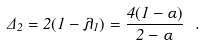Convert formula to latex. <formula><loc_0><loc_0><loc_500><loc_500>\Delta _ { 2 } = 2 ( 1 - \lambda _ { 1 } ) = \frac { 4 ( 1 - \alpha ) } { 2 - \alpha } \ .</formula> 